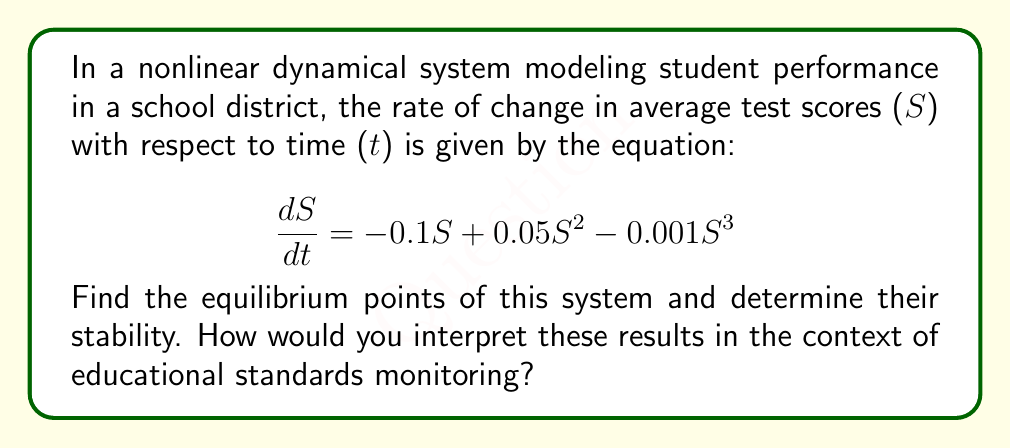Teach me how to tackle this problem. 1. To find the equilibrium points, set $\frac{dS}{dt} = 0$:

   $$-0.1S + 0.05S^2 - 0.001S^3 = 0$$

2. Factor out S:
   
   $$S(-0.1 + 0.05S - 0.001S^2) = 0$$

3. Solve the equation:
   $S = 0$ or $-0.1 + 0.05S - 0.001S^2 = 0$

4. For the quadratic equation, use the quadratic formula:
   
   $$S = \frac{-b \pm \sqrt{b^2 - 4ac}}{2a}$$
   
   Where $a = -0.001$, $b = 0.05$, and $c = -0.1$

5. Solving this gives us three equilibrium points:
   $S_1 = 0$, $S_2 \approx 10$, and $S_3 \approx 40$

6. To determine stability, evaluate $\frac{d}{dS}(\frac{dS}{dt})$ at each point:

   $$\frac{d}{dS}(\frac{dS}{dt}) = -0.1 + 0.1S - 0.003S^2$$

7. Evaluate at each point:
   At $S_1 = 0$: $-0.1 < 0$ (stable)
   At $S_2 = 10$: $0.7 > 0$ (unstable)
   At $S_3 = 40$: $-3.7 < 0$ (stable)

8. Interpretation: The system has three equilibrium points. $S_1 = 0$ represents a stable low-performance state, $S_2 = 10$ is an unstable threshold, and $S_3 = 40$ represents a stable high-performance state. The unstable point $S_2$ acts as a tipping point between the two stable states.
Answer: Three equilibrium points: $S_1 = 0$ (stable), $S_2 \approx 10$ (unstable), $S_3 \approx 40$ (stable). 